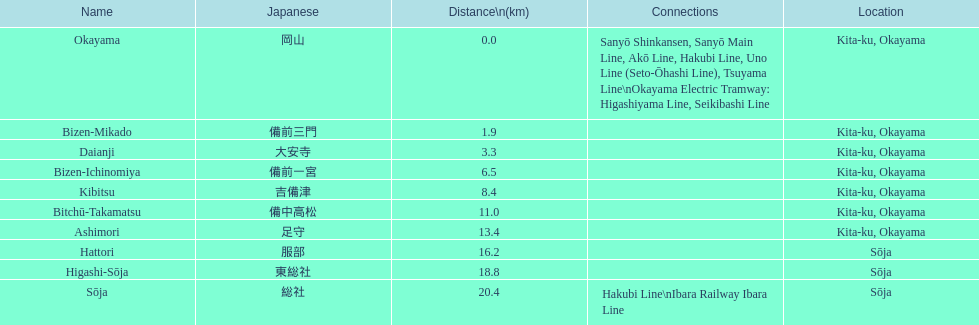Which has a distance of more than 1 kilometer but less than 2 kilometers? Bizen-Mikado. Can you give me this table as a dict? {'header': ['Name', 'Japanese', 'Distance\\n(km)', 'Connections', 'Location'], 'rows': [['Okayama', '岡山', '0.0', 'Sanyō Shinkansen, Sanyō Main Line, Akō Line, Hakubi Line, Uno Line (Seto-Ōhashi Line), Tsuyama Line\\nOkayama Electric Tramway: Higashiyama Line, Seikibashi Line', 'Kita-ku, Okayama'], ['Bizen-Mikado', '備前三門', '1.9', '', 'Kita-ku, Okayama'], ['Daianji', '大安寺', '3.3', '', 'Kita-ku, Okayama'], ['Bizen-Ichinomiya', '備前一宮', '6.5', '', 'Kita-ku, Okayama'], ['Kibitsu', '吉備津', '8.4', '', 'Kita-ku, Okayama'], ['Bitchū-Takamatsu', '備中高松', '11.0', '', 'Kita-ku, Okayama'], ['Ashimori', '足守', '13.4', '', 'Kita-ku, Okayama'], ['Hattori', '服部', '16.2', '', 'Sōja'], ['Higashi-Sōja', '東総社', '18.8', '', 'Sōja'], ['Sōja', '総社', '20.4', 'Hakubi Line\\nIbara Railway Ibara Line', 'Sōja']]} 